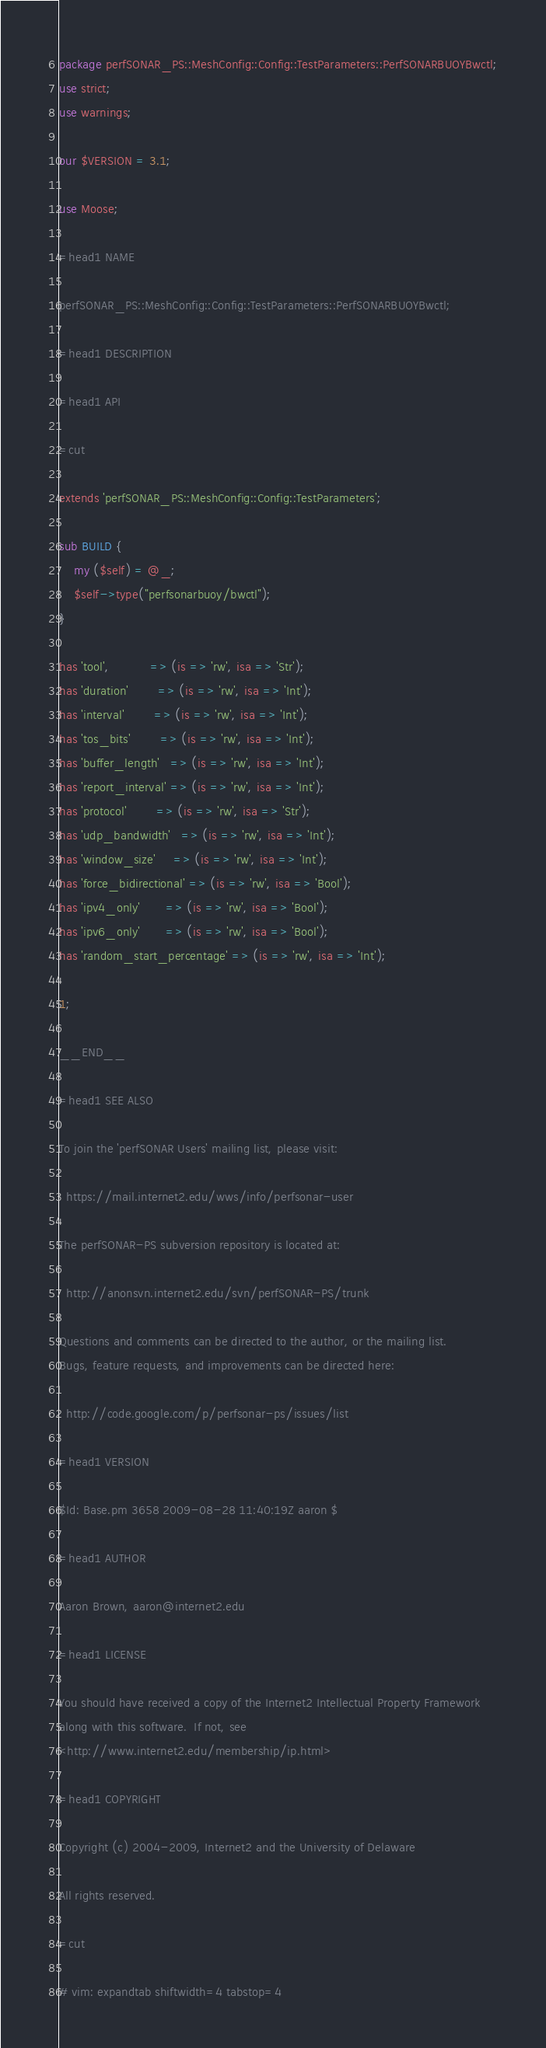Convert code to text. <code><loc_0><loc_0><loc_500><loc_500><_Perl_>package perfSONAR_PS::MeshConfig::Config::TestParameters::PerfSONARBUOYBwctl;
use strict;
use warnings;

our $VERSION = 3.1;

use Moose;

=head1 NAME

perfSONAR_PS::MeshConfig::Config::TestParameters::PerfSONARBUOYBwctl;

=head1 DESCRIPTION

=head1 API

=cut

extends 'perfSONAR_PS::MeshConfig::Config::TestParameters';

sub BUILD {
    my ($self) = @_;
    $self->type("perfsonarbuoy/bwctl");
}

has 'tool',           => (is => 'rw', isa => 'Str');
has 'duration'        => (is => 'rw', isa => 'Int');
has 'interval'        => (is => 'rw', isa => 'Int');
has 'tos_bits'        => (is => 'rw', isa => 'Int');
has 'buffer_length'   => (is => 'rw', isa => 'Int');
has 'report_interval' => (is => 'rw', isa => 'Int');
has 'protocol'        => (is => 'rw', isa => 'Str');
has 'udp_bandwidth'   => (is => 'rw', isa => 'Int');
has 'window_size'     => (is => 'rw', isa => 'Int');
has 'force_bidirectional' => (is => 'rw', isa => 'Bool');
has 'ipv4_only'       => (is => 'rw', isa => 'Bool');
has 'ipv6_only'       => (is => 'rw', isa => 'Bool');
has 'random_start_percentage' => (is => 'rw', isa => 'Int');

1;

__END__

=head1 SEE ALSO

To join the 'perfSONAR Users' mailing list, please visit:

  https://mail.internet2.edu/wws/info/perfsonar-user

The perfSONAR-PS subversion repository is located at:

  http://anonsvn.internet2.edu/svn/perfSONAR-PS/trunk

Questions and comments can be directed to the author, or the mailing list.
Bugs, feature requests, and improvements can be directed here:

  http://code.google.com/p/perfsonar-ps/issues/list

=head1 VERSION

$Id: Base.pm 3658 2009-08-28 11:40:19Z aaron $

=head1 AUTHOR

Aaron Brown, aaron@internet2.edu

=head1 LICENSE

You should have received a copy of the Internet2 Intellectual Property Framework
along with this software.  If not, see
<http://www.internet2.edu/membership/ip.html>

=head1 COPYRIGHT

Copyright (c) 2004-2009, Internet2 and the University of Delaware

All rights reserved.

=cut

# vim: expandtab shiftwidth=4 tabstop=4
</code> 